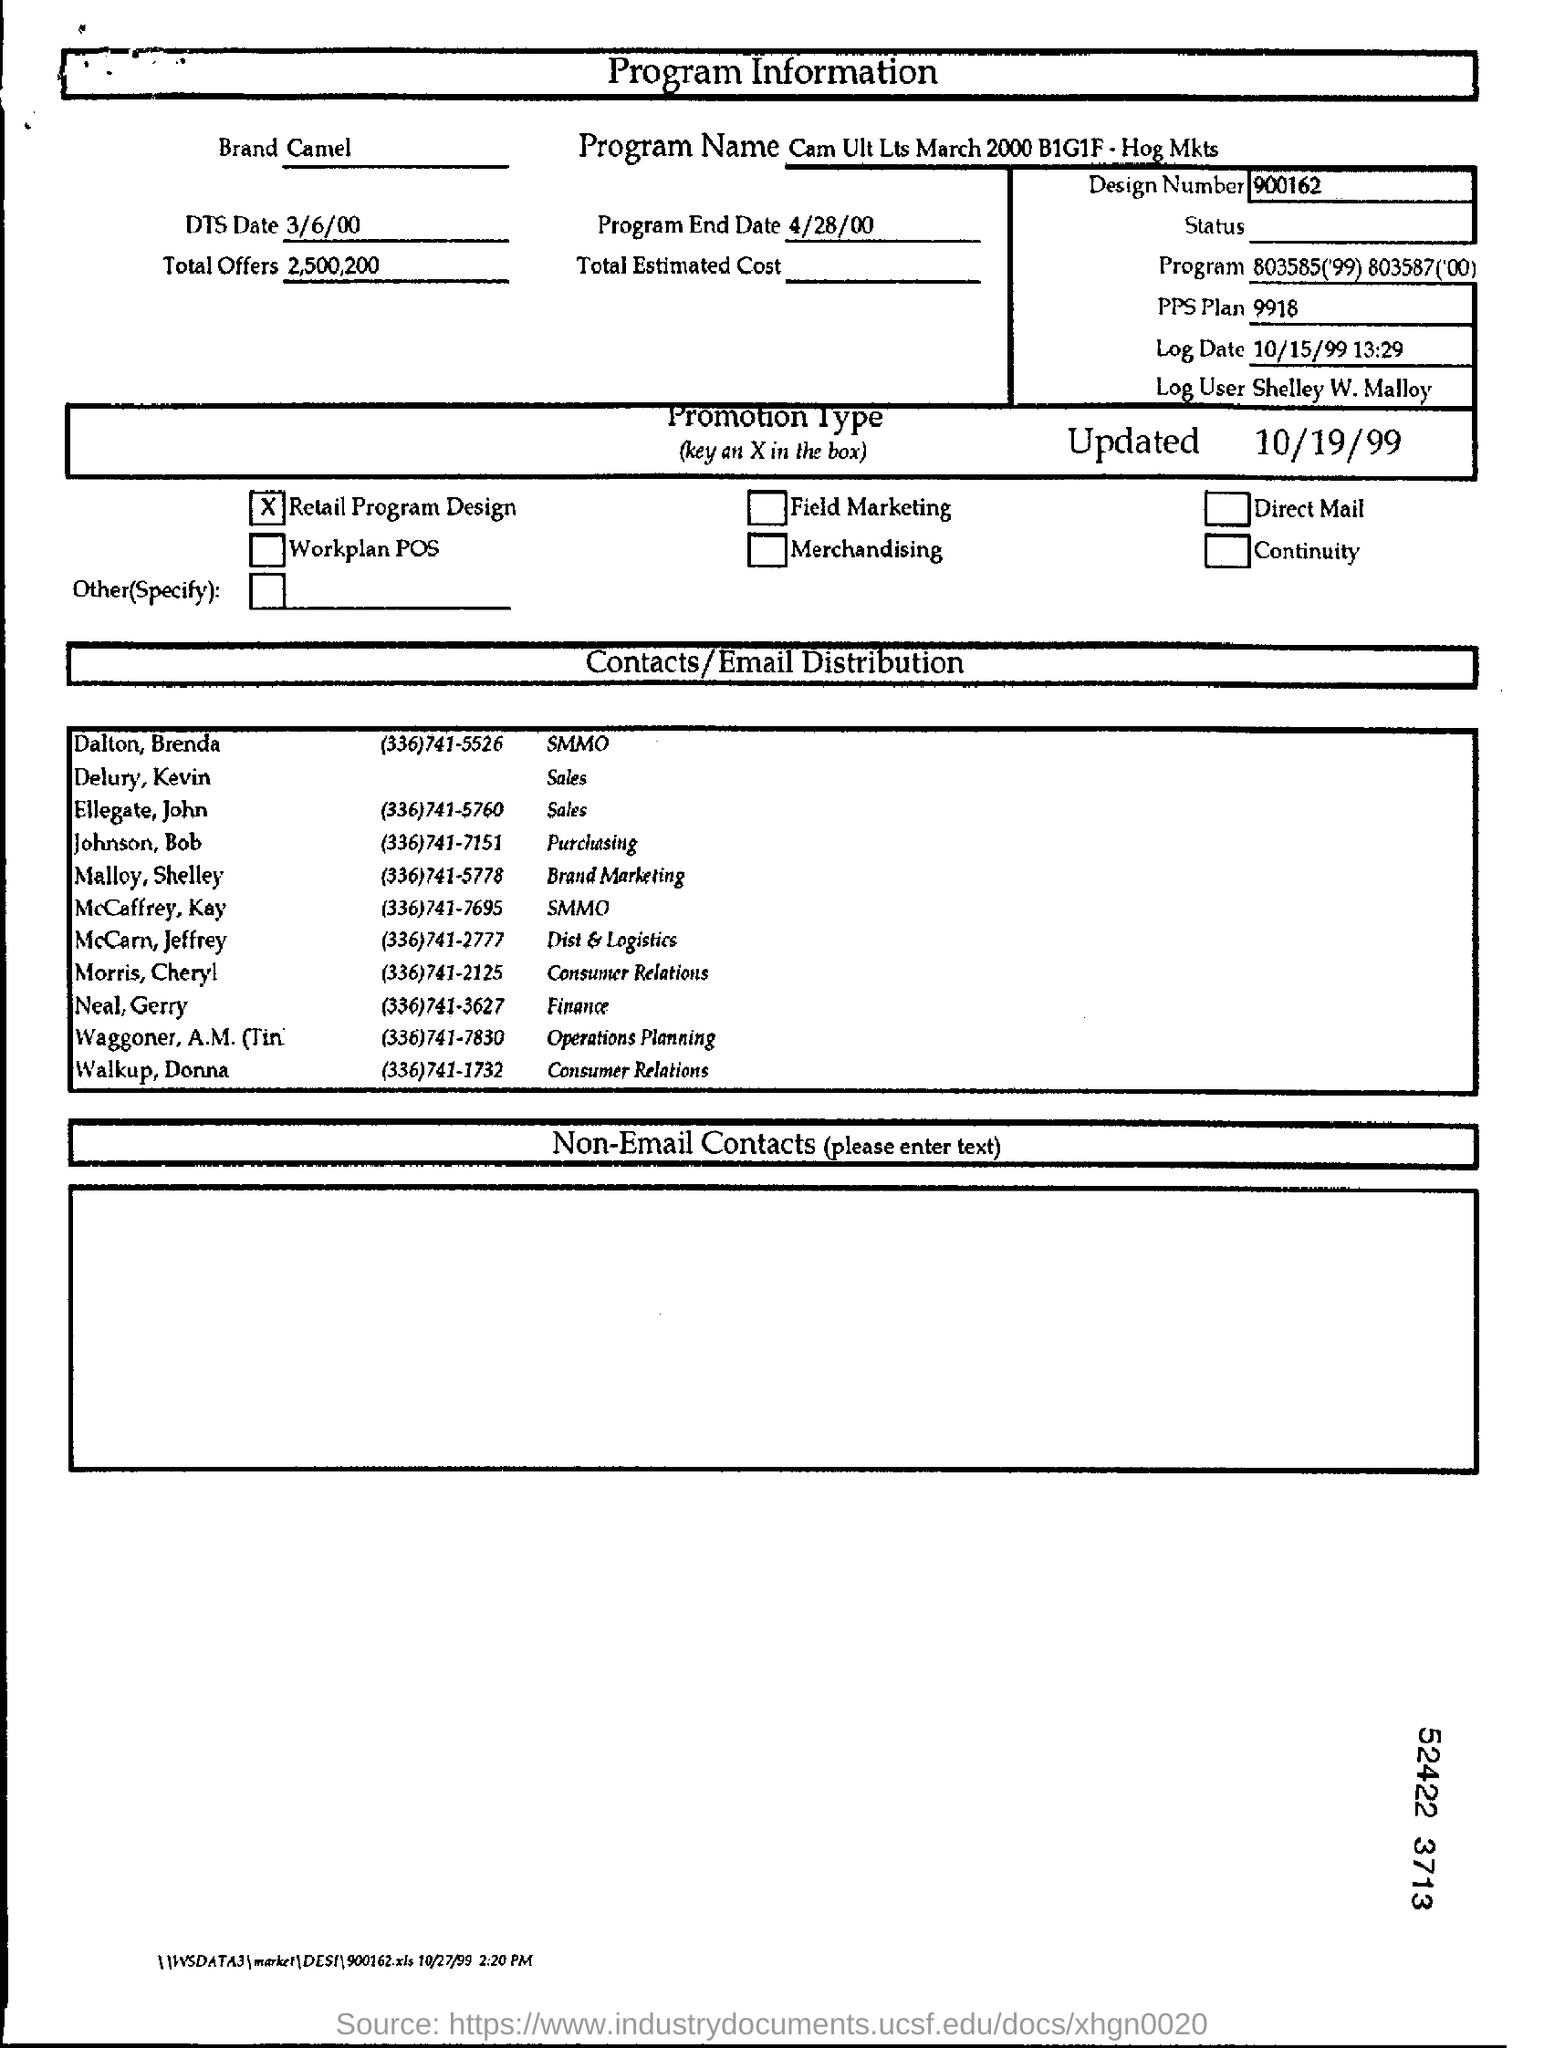What is the program name?
Your answer should be compact. Cam Ult Lts March 2000 B1G1F - Hog Mkts. What is the brand?
Make the answer very short. Camel. What is DTS Date?
Your response must be concise. 3/6/00. What is Program End Date?
Give a very brief answer. 4/28/00. What is the total offers?
Give a very brief answer. 2,500,200. What is the design number?
Offer a very short reply. 900162. What is the log date?
Provide a succinct answer. 10/15/99. What is the name of log user?
Offer a very short reply. Shelley W. Malloy. 